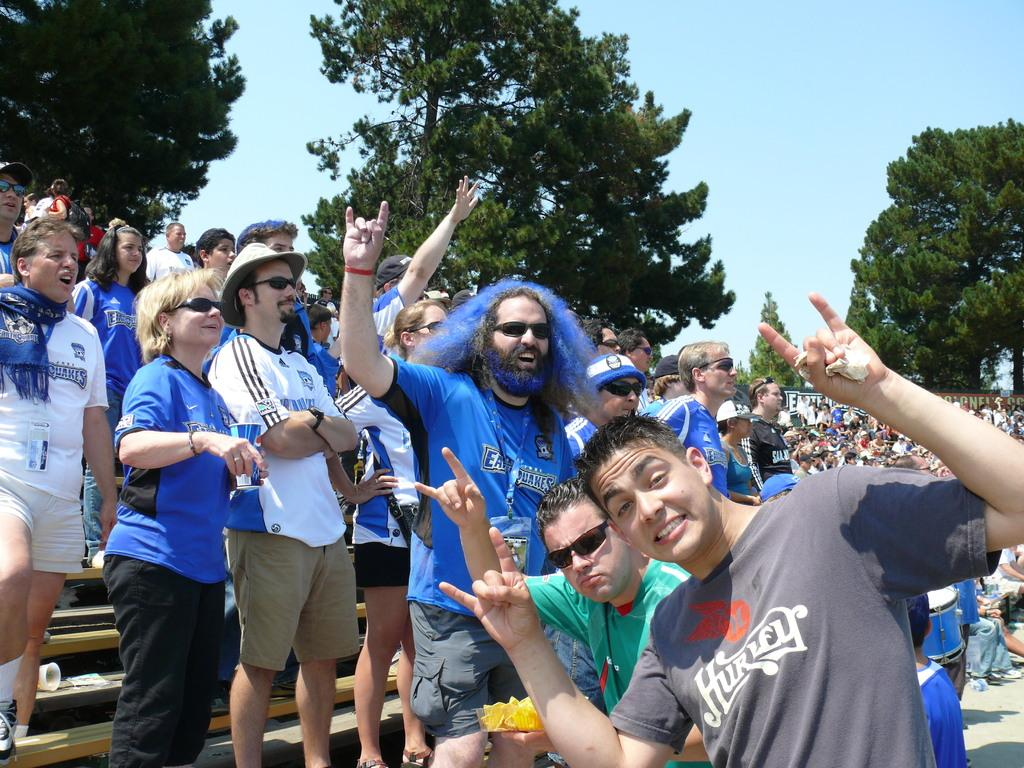How many people are present in the image? There are many people in the image. What are some of the people holding in their hands? Some people are holding objects in their hands. What type of natural environment is visible in the image? There are many trees in the image. What is visible in the upper part of the image? The sky is visible in the image. What type of scent can be detected from the library in the image? There is no library present in the image, so it is not possible to detect any scent. 